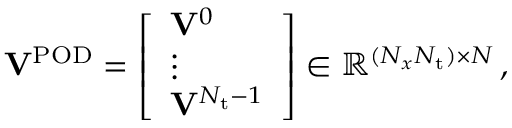<formula> <loc_0><loc_0><loc_500><loc_500>\begin{array} { r } { V ^ { P O D } = \left [ \begin{array} { l } { V ^ { 0 } } \\ { \vdots } \\ { V ^ { N _ { t } - 1 } } \end{array} \right ] \in \mathbb { R } ^ { ( N _ { x } N _ { t } ) \times N } \, , } \end{array}</formula> 